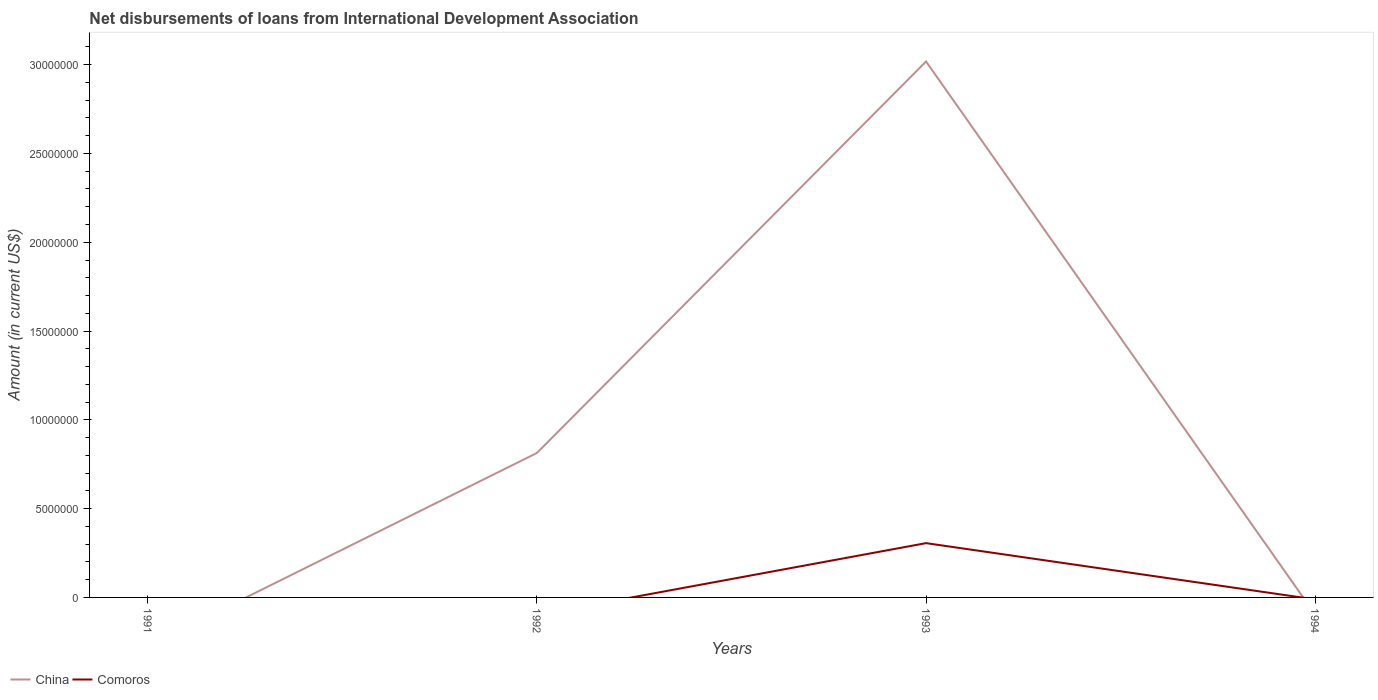How many different coloured lines are there?
Offer a terse response. 2. Does the line corresponding to Comoros intersect with the line corresponding to China?
Your answer should be very brief. Yes. Is the number of lines equal to the number of legend labels?
Ensure brevity in your answer.  No. Across all years, what is the maximum amount of loans disbursed in China?
Offer a very short reply. 0. What is the total amount of loans disbursed in China in the graph?
Provide a succinct answer. -2.20e+07. What is the difference between the highest and the second highest amount of loans disbursed in Comoros?
Provide a succinct answer. 3.06e+06. How many lines are there?
Keep it short and to the point. 2. What is the difference between two consecutive major ticks on the Y-axis?
Your answer should be very brief. 5.00e+06. Does the graph contain any zero values?
Your answer should be very brief. Yes. Where does the legend appear in the graph?
Offer a very short reply. Bottom left. How many legend labels are there?
Your answer should be compact. 2. What is the title of the graph?
Your answer should be compact. Net disbursements of loans from International Development Association. Does "Afghanistan" appear as one of the legend labels in the graph?
Provide a short and direct response. No. What is the label or title of the X-axis?
Provide a short and direct response. Years. What is the Amount (in current US$) of Comoros in 1991?
Your response must be concise. 0. What is the Amount (in current US$) in China in 1992?
Ensure brevity in your answer.  8.14e+06. What is the Amount (in current US$) in China in 1993?
Your answer should be compact. 3.02e+07. What is the Amount (in current US$) of Comoros in 1993?
Your response must be concise. 3.06e+06. What is the Amount (in current US$) of China in 1994?
Provide a short and direct response. 0. Across all years, what is the maximum Amount (in current US$) in China?
Offer a terse response. 3.02e+07. Across all years, what is the maximum Amount (in current US$) in Comoros?
Provide a short and direct response. 3.06e+06. Across all years, what is the minimum Amount (in current US$) of China?
Your answer should be compact. 0. What is the total Amount (in current US$) in China in the graph?
Provide a short and direct response. 3.83e+07. What is the total Amount (in current US$) in Comoros in the graph?
Provide a short and direct response. 3.06e+06. What is the difference between the Amount (in current US$) of China in 1992 and that in 1993?
Provide a succinct answer. -2.20e+07. What is the difference between the Amount (in current US$) in China in 1992 and the Amount (in current US$) in Comoros in 1993?
Your answer should be compact. 5.08e+06. What is the average Amount (in current US$) of China per year?
Your answer should be compact. 9.58e+06. What is the average Amount (in current US$) in Comoros per year?
Provide a short and direct response. 7.64e+05. In the year 1993, what is the difference between the Amount (in current US$) of China and Amount (in current US$) of Comoros?
Keep it short and to the point. 2.71e+07. What is the ratio of the Amount (in current US$) in China in 1992 to that in 1993?
Ensure brevity in your answer.  0.27. What is the difference between the highest and the lowest Amount (in current US$) in China?
Provide a succinct answer. 3.02e+07. What is the difference between the highest and the lowest Amount (in current US$) in Comoros?
Ensure brevity in your answer.  3.06e+06. 